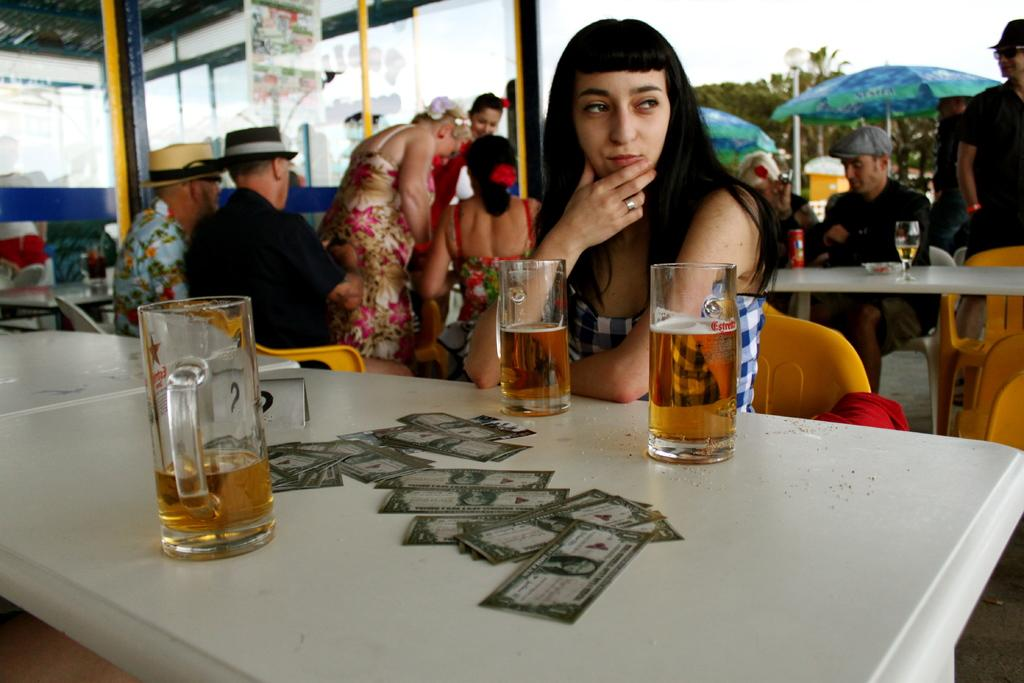What are the people in the room doing? There are people standing and sitting on chairs in the room. What is on the table in the room? The table has cards and wine bottles on it. What is the lighting condition in the image? The background of the image is sunny. What type of committee is meeting in the room? There is no indication of a committee meeting in the room; the image only shows people standing and sitting, as well as a table with cards and wine bottles. Can you tell me how many zebras are present in the room? There are no zebras present in the room; the image only features people, chairs, a table, cards, and wine bottles. 